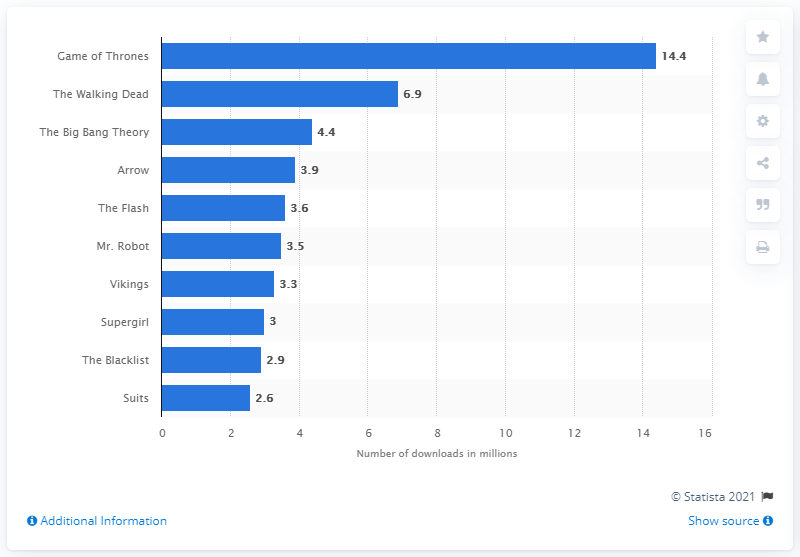Highlight a few significant elements in this photo. The Walking Dead was the cable TV show with the highest number of viewers in 2015. In 2015, the most-pirated TV show was "Game of Thrones. The most downloaded episode of "Game of Thrones" was downloaded 14.4 times. 